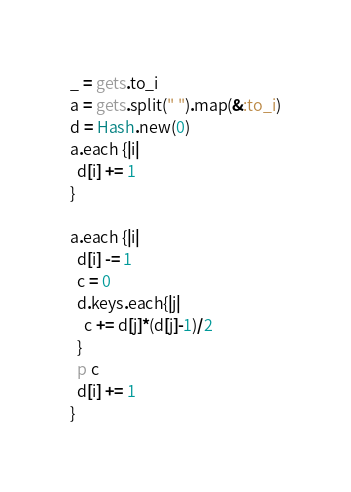<code> <loc_0><loc_0><loc_500><loc_500><_Ruby_>_ = gets.to_i
a = gets.split(" ").map(&:to_i)
d = Hash.new(0)
a.each {|i|
  d[i] += 1
}

a.each {|i|
  d[i] -= 1
  c = 0
  d.keys.each{|j|
    c += d[j]*(d[j]-1)/2
  }
  p c
  d[i] += 1
}</code> 